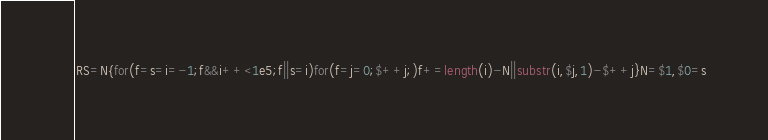<code> <loc_0><loc_0><loc_500><loc_500><_Awk_>RS=N{for(f=s=i=-1;f&&i++<1e5;f||s=i)for(f=j=0;$++j;)f+=length(i)-N||substr(i,$j,1)-$++j}N=$1,$0=s</code> 